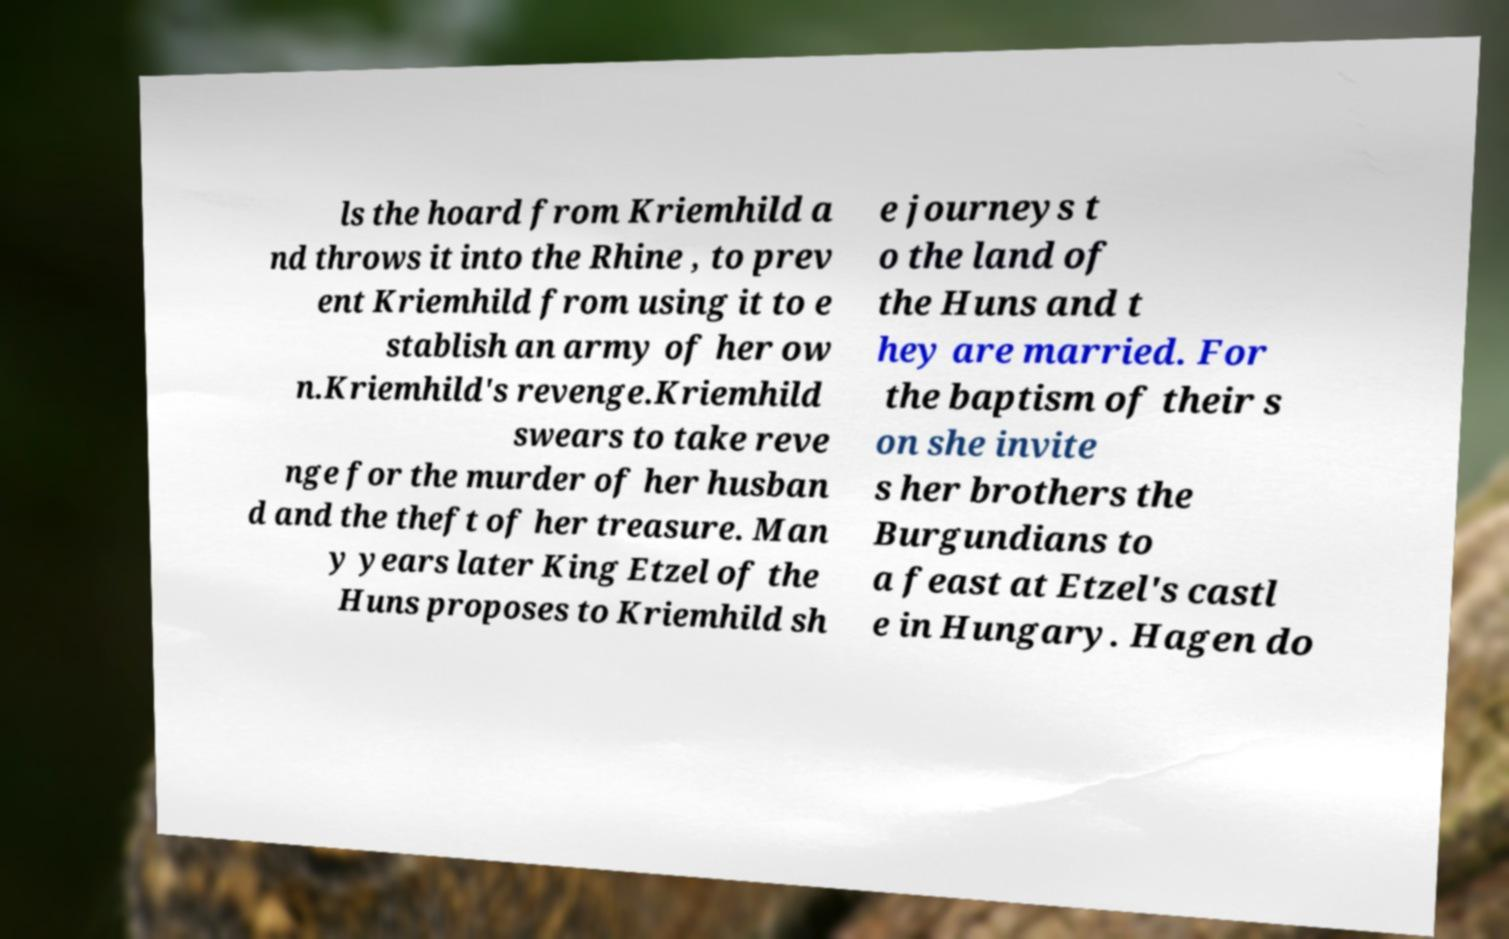For documentation purposes, I need the text within this image transcribed. Could you provide that? ls the hoard from Kriemhild a nd throws it into the Rhine , to prev ent Kriemhild from using it to e stablish an army of her ow n.Kriemhild's revenge.Kriemhild swears to take reve nge for the murder of her husban d and the theft of her treasure. Man y years later King Etzel of the Huns proposes to Kriemhild sh e journeys t o the land of the Huns and t hey are married. For the baptism of their s on she invite s her brothers the Burgundians to a feast at Etzel's castl e in Hungary. Hagen do 